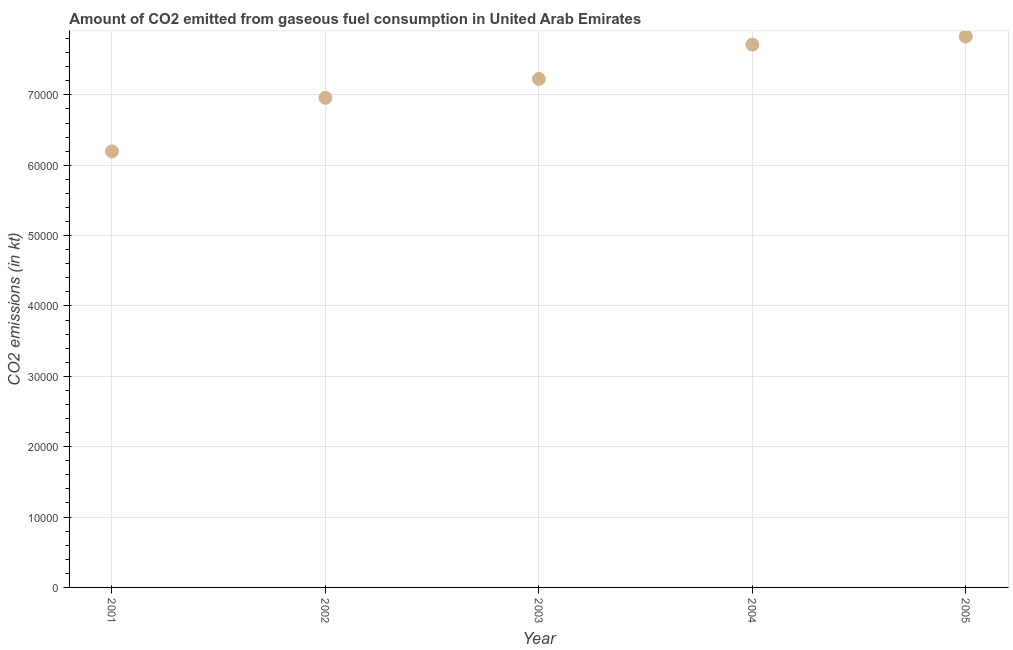What is the co2 emissions from gaseous fuel consumption in 2002?
Your answer should be very brief. 6.96e+04. Across all years, what is the maximum co2 emissions from gaseous fuel consumption?
Ensure brevity in your answer.  7.83e+04. Across all years, what is the minimum co2 emissions from gaseous fuel consumption?
Ensure brevity in your answer.  6.20e+04. In which year was the co2 emissions from gaseous fuel consumption maximum?
Provide a short and direct response. 2005. In which year was the co2 emissions from gaseous fuel consumption minimum?
Ensure brevity in your answer.  2001. What is the sum of the co2 emissions from gaseous fuel consumption?
Your response must be concise. 3.59e+05. What is the difference between the co2 emissions from gaseous fuel consumption in 2002 and 2005?
Give a very brief answer. -8705.46. What is the average co2 emissions from gaseous fuel consumption per year?
Your answer should be compact. 7.19e+04. What is the median co2 emissions from gaseous fuel consumption?
Make the answer very short. 7.23e+04. In how many years, is the co2 emissions from gaseous fuel consumption greater than 10000 kt?
Your answer should be compact. 5. Do a majority of the years between 2005 and 2003 (inclusive) have co2 emissions from gaseous fuel consumption greater than 70000 kt?
Offer a very short reply. No. What is the ratio of the co2 emissions from gaseous fuel consumption in 2001 to that in 2002?
Offer a terse response. 0.89. Is the co2 emissions from gaseous fuel consumption in 2003 less than that in 2005?
Your answer should be very brief. Yes. Is the difference between the co2 emissions from gaseous fuel consumption in 2001 and 2004 greater than the difference between any two years?
Offer a terse response. No. What is the difference between the highest and the second highest co2 emissions from gaseous fuel consumption?
Make the answer very short. 1151.44. What is the difference between the highest and the lowest co2 emissions from gaseous fuel consumption?
Your response must be concise. 1.63e+04. In how many years, is the co2 emissions from gaseous fuel consumption greater than the average co2 emissions from gaseous fuel consumption taken over all years?
Your answer should be very brief. 3. Does the co2 emissions from gaseous fuel consumption monotonically increase over the years?
Your answer should be compact. Yes. How many dotlines are there?
Your answer should be very brief. 1. Are the values on the major ticks of Y-axis written in scientific E-notation?
Give a very brief answer. No. Does the graph contain grids?
Provide a short and direct response. Yes. What is the title of the graph?
Your response must be concise. Amount of CO2 emitted from gaseous fuel consumption in United Arab Emirates. What is the label or title of the X-axis?
Your answer should be very brief. Year. What is the label or title of the Y-axis?
Provide a succinct answer. CO2 emissions (in kt). What is the CO2 emissions (in kt) in 2001?
Ensure brevity in your answer.  6.20e+04. What is the CO2 emissions (in kt) in 2002?
Give a very brief answer. 6.96e+04. What is the CO2 emissions (in kt) in 2003?
Offer a very short reply. 7.23e+04. What is the CO2 emissions (in kt) in 2004?
Provide a short and direct response. 7.71e+04. What is the CO2 emissions (in kt) in 2005?
Make the answer very short. 7.83e+04. What is the difference between the CO2 emissions (in kt) in 2001 and 2002?
Provide a succinct answer. -7605.36. What is the difference between the CO2 emissions (in kt) in 2001 and 2003?
Keep it short and to the point. -1.03e+04. What is the difference between the CO2 emissions (in kt) in 2001 and 2004?
Your answer should be very brief. -1.52e+04. What is the difference between the CO2 emissions (in kt) in 2001 and 2005?
Provide a short and direct response. -1.63e+04. What is the difference between the CO2 emissions (in kt) in 2002 and 2003?
Provide a succinct answer. -2687.91. What is the difference between the CO2 emissions (in kt) in 2002 and 2004?
Offer a very short reply. -7554.02. What is the difference between the CO2 emissions (in kt) in 2002 and 2005?
Your answer should be very brief. -8705.46. What is the difference between the CO2 emissions (in kt) in 2003 and 2004?
Your response must be concise. -4866.11. What is the difference between the CO2 emissions (in kt) in 2003 and 2005?
Give a very brief answer. -6017.55. What is the difference between the CO2 emissions (in kt) in 2004 and 2005?
Offer a very short reply. -1151.44. What is the ratio of the CO2 emissions (in kt) in 2001 to that in 2002?
Your answer should be compact. 0.89. What is the ratio of the CO2 emissions (in kt) in 2001 to that in 2003?
Ensure brevity in your answer.  0.86. What is the ratio of the CO2 emissions (in kt) in 2001 to that in 2004?
Your response must be concise. 0.8. What is the ratio of the CO2 emissions (in kt) in 2001 to that in 2005?
Ensure brevity in your answer.  0.79. What is the ratio of the CO2 emissions (in kt) in 2002 to that in 2003?
Keep it short and to the point. 0.96. What is the ratio of the CO2 emissions (in kt) in 2002 to that in 2004?
Your answer should be compact. 0.9. What is the ratio of the CO2 emissions (in kt) in 2002 to that in 2005?
Your response must be concise. 0.89. What is the ratio of the CO2 emissions (in kt) in 2003 to that in 2004?
Provide a succinct answer. 0.94. What is the ratio of the CO2 emissions (in kt) in 2003 to that in 2005?
Keep it short and to the point. 0.92. What is the ratio of the CO2 emissions (in kt) in 2004 to that in 2005?
Keep it short and to the point. 0.98. 